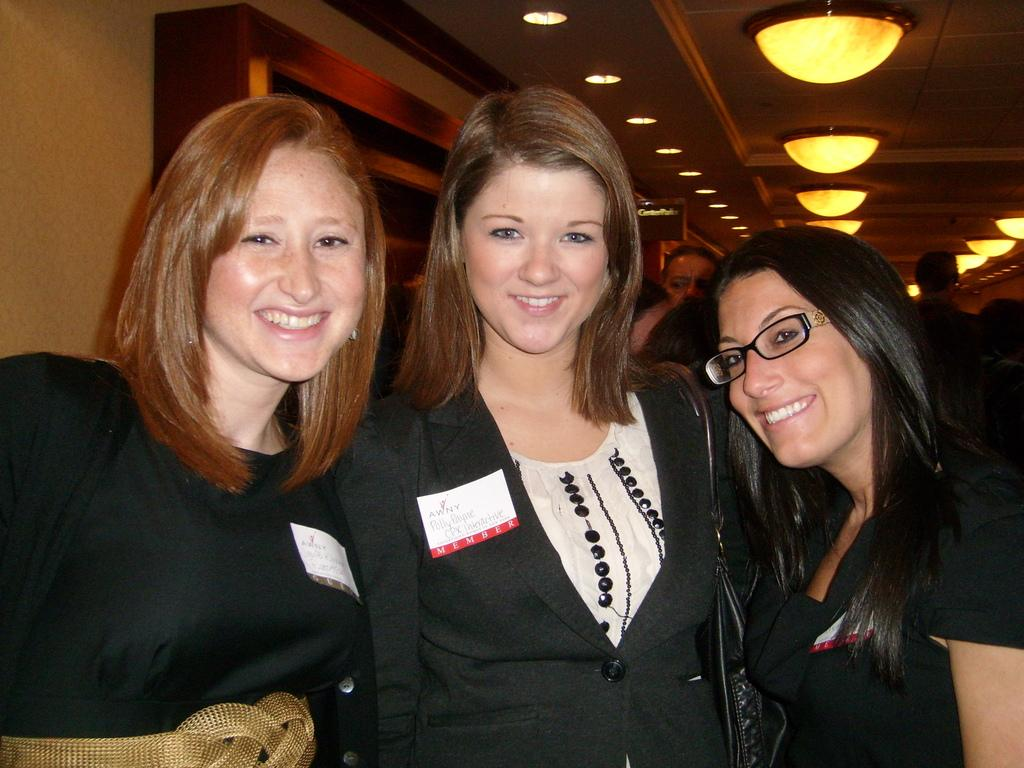How many people are in the image? There are three persons in the image. What can be observed about the costumes of the persons? The three persons are in different costumes. What is the facial expression of the persons? The persons are smiling. What can be seen in the background of the image? There is a wall and lights in the background of the image, along with a few people. What type of competition is taking place in the image? There is no competition present in the image; it features three persons in different costumes and smiling. How does the feeling of the persons change throughout the image? The image only shows the persons smiling, so there is no indication of a change in their feelings. 